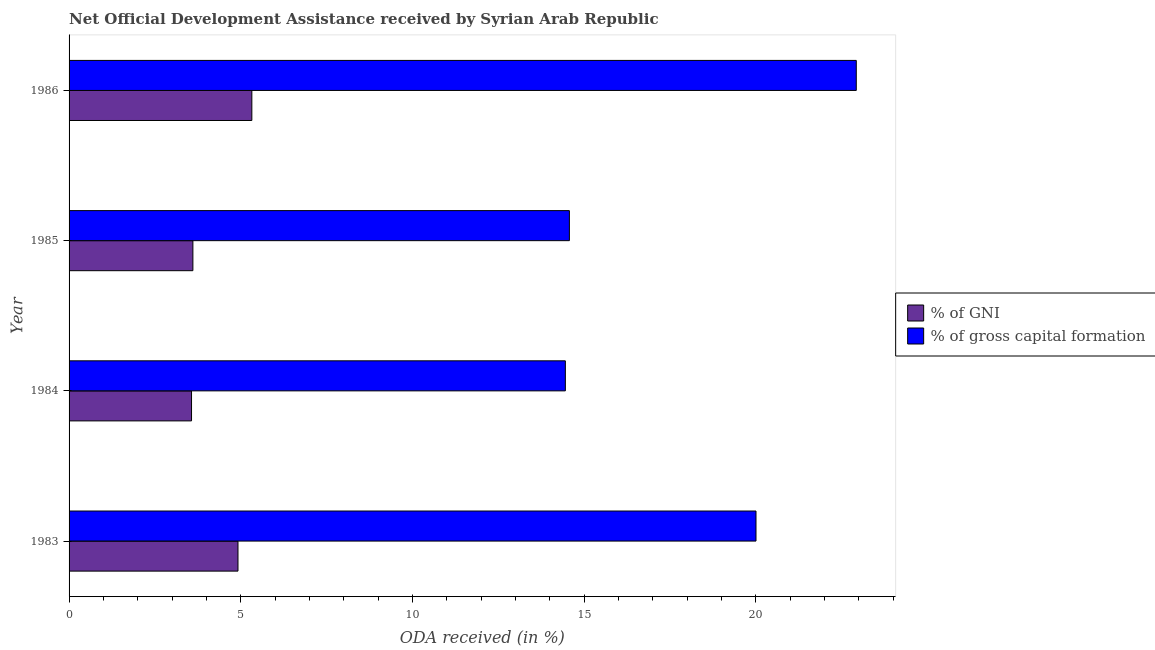How many different coloured bars are there?
Offer a terse response. 2. Are the number of bars on each tick of the Y-axis equal?
Offer a terse response. Yes. How many bars are there on the 2nd tick from the top?
Give a very brief answer. 2. What is the label of the 4th group of bars from the top?
Keep it short and to the point. 1983. What is the oda received as percentage of gni in 1983?
Your answer should be very brief. 4.92. Across all years, what is the maximum oda received as percentage of gni?
Offer a terse response. 5.32. Across all years, what is the minimum oda received as percentage of gni?
Offer a very short reply. 3.57. What is the total oda received as percentage of gross capital formation in the graph?
Offer a terse response. 71.95. What is the difference between the oda received as percentage of gross capital formation in 1983 and that in 1986?
Your response must be concise. -2.92. What is the difference between the oda received as percentage of gross capital formation in 1986 and the oda received as percentage of gni in 1984?
Keep it short and to the point. 19.36. What is the average oda received as percentage of gross capital formation per year?
Provide a succinct answer. 17.99. In the year 1986, what is the difference between the oda received as percentage of gni and oda received as percentage of gross capital formation?
Make the answer very short. -17.6. In how many years, is the oda received as percentage of gross capital formation greater than 22 %?
Provide a succinct answer. 1. What is the ratio of the oda received as percentage of gross capital formation in 1983 to that in 1984?
Make the answer very short. 1.38. Is the oda received as percentage of gni in 1984 less than that in 1986?
Keep it short and to the point. Yes. Is the difference between the oda received as percentage of gross capital formation in 1984 and 1985 greater than the difference between the oda received as percentage of gni in 1984 and 1985?
Your answer should be very brief. No. What is the difference between the highest and the second highest oda received as percentage of gni?
Provide a short and direct response. 0.4. What is the difference between the highest and the lowest oda received as percentage of gross capital formation?
Offer a very short reply. 8.47. Is the sum of the oda received as percentage of gross capital formation in 1983 and 1986 greater than the maximum oda received as percentage of gni across all years?
Ensure brevity in your answer.  Yes. What does the 2nd bar from the top in 1984 represents?
Give a very brief answer. % of GNI. What does the 2nd bar from the bottom in 1984 represents?
Ensure brevity in your answer.  % of gross capital formation. How many bars are there?
Your response must be concise. 8. Are all the bars in the graph horizontal?
Keep it short and to the point. Yes. What is the difference between two consecutive major ticks on the X-axis?
Offer a very short reply. 5. Does the graph contain any zero values?
Your response must be concise. No. Does the graph contain grids?
Provide a short and direct response. No. Where does the legend appear in the graph?
Your response must be concise. Center right. What is the title of the graph?
Your answer should be compact. Net Official Development Assistance received by Syrian Arab Republic. What is the label or title of the X-axis?
Give a very brief answer. ODA received (in %). What is the ODA received (in %) of % of GNI in 1983?
Offer a very short reply. 4.92. What is the ODA received (in %) in % of gross capital formation in 1983?
Your answer should be compact. 20. What is the ODA received (in %) in % of GNI in 1984?
Offer a very short reply. 3.57. What is the ODA received (in %) in % of gross capital formation in 1984?
Offer a terse response. 14.45. What is the ODA received (in %) in % of GNI in 1985?
Make the answer very short. 3.61. What is the ODA received (in %) of % of gross capital formation in 1985?
Ensure brevity in your answer.  14.57. What is the ODA received (in %) in % of GNI in 1986?
Provide a short and direct response. 5.32. What is the ODA received (in %) of % of gross capital formation in 1986?
Your answer should be very brief. 22.93. Across all years, what is the maximum ODA received (in %) in % of GNI?
Provide a succinct answer. 5.32. Across all years, what is the maximum ODA received (in %) in % of gross capital formation?
Offer a very short reply. 22.93. Across all years, what is the minimum ODA received (in %) of % of GNI?
Your response must be concise. 3.57. Across all years, what is the minimum ODA received (in %) of % of gross capital formation?
Make the answer very short. 14.45. What is the total ODA received (in %) in % of GNI in the graph?
Ensure brevity in your answer.  17.41. What is the total ODA received (in %) of % of gross capital formation in the graph?
Your answer should be very brief. 71.95. What is the difference between the ODA received (in %) of % of GNI in 1983 and that in 1984?
Your answer should be compact. 1.35. What is the difference between the ODA received (in %) in % of gross capital formation in 1983 and that in 1984?
Provide a short and direct response. 5.55. What is the difference between the ODA received (in %) of % of GNI in 1983 and that in 1985?
Ensure brevity in your answer.  1.31. What is the difference between the ODA received (in %) of % of gross capital formation in 1983 and that in 1985?
Your answer should be very brief. 5.43. What is the difference between the ODA received (in %) of % of GNI in 1983 and that in 1986?
Your answer should be very brief. -0.4. What is the difference between the ODA received (in %) of % of gross capital formation in 1983 and that in 1986?
Provide a succinct answer. -2.92. What is the difference between the ODA received (in %) of % of GNI in 1984 and that in 1985?
Your answer should be compact. -0.04. What is the difference between the ODA received (in %) in % of gross capital formation in 1984 and that in 1985?
Offer a very short reply. -0.12. What is the difference between the ODA received (in %) in % of GNI in 1984 and that in 1986?
Keep it short and to the point. -1.76. What is the difference between the ODA received (in %) in % of gross capital formation in 1984 and that in 1986?
Make the answer very short. -8.47. What is the difference between the ODA received (in %) of % of GNI in 1985 and that in 1986?
Give a very brief answer. -1.72. What is the difference between the ODA received (in %) in % of gross capital formation in 1985 and that in 1986?
Your answer should be very brief. -8.35. What is the difference between the ODA received (in %) of % of GNI in 1983 and the ODA received (in %) of % of gross capital formation in 1984?
Offer a very short reply. -9.53. What is the difference between the ODA received (in %) of % of GNI in 1983 and the ODA received (in %) of % of gross capital formation in 1985?
Your answer should be compact. -9.65. What is the difference between the ODA received (in %) of % of GNI in 1983 and the ODA received (in %) of % of gross capital formation in 1986?
Offer a terse response. -18.01. What is the difference between the ODA received (in %) of % of GNI in 1984 and the ODA received (in %) of % of gross capital formation in 1985?
Your response must be concise. -11. What is the difference between the ODA received (in %) in % of GNI in 1984 and the ODA received (in %) in % of gross capital formation in 1986?
Provide a short and direct response. -19.36. What is the difference between the ODA received (in %) in % of GNI in 1985 and the ODA received (in %) in % of gross capital formation in 1986?
Your answer should be compact. -19.32. What is the average ODA received (in %) in % of GNI per year?
Offer a very short reply. 4.35. What is the average ODA received (in %) in % of gross capital formation per year?
Make the answer very short. 17.99. In the year 1983, what is the difference between the ODA received (in %) in % of GNI and ODA received (in %) in % of gross capital formation?
Your answer should be very brief. -15.09. In the year 1984, what is the difference between the ODA received (in %) of % of GNI and ODA received (in %) of % of gross capital formation?
Give a very brief answer. -10.89. In the year 1985, what is the difference between the ODA received (in %) of % of GNI and ODA received (in %) of % of gross capital formation?
Ensure brevity in your answer.  -10.96. In the year 1986, what is the difference between the ODA received (in %) in % of GNI and ODA received (in %) in % of gross capital formation?
Your answer should be very brief. -17.6. What is the ratio of the ODA received (in %) in % of GNI in 1983 to that in 1984?
Offer a terse response. 1.38. What is the ratio of the ODA received (in %) in % of gross capital formation in 1983 to that in 1984?
Keep it short and to the point. 1.38. What is the ratio of the ODA received (in %) in % of GNI in 1983 to that in 1985?
Your response must be concise. 1.36. What is the ratio of the ODA received (in %) in % of gross capital formation in 1983 to that in 1985?
Your answer should be compact. 1.37. What is the ratio of the ODA received (in %) of % of GNI in 1983 to that in 1986?
Give a very brief answer. 0.92. What is the ratio of the ODA received (in %) of % of gross capital formation in 1983 to that in 1986?
Ensure brevity in your answer.  0.87. What is the ratio of the ODA received (in %) of % of GNI in 1984 to that in 1985?
Ensure brevity in your answer.  0.99. What is the ratio of the ODA received (in %) of % of GNI in 1984 to that in 1986?
Your answer should be very brief. 0.67. What is the ratio of the ODA received (in %) of % of gross capital formation in 1984 to that in 1986?
Keep it short and to the point. 0.63. What is the ratio of the ODA received (in %) of % of GNI in 1985 to that in 1986?
Provide a short and direct response. 0.68. What is the ratio of the ODA received (in %) of % of gross capital formation in 1985 to that in 1986?
Offer a very short reply. 0.64. What is the difference between the highest and the second highest ODA received (in %) of % of GNI?
Your answer should be compact. 0.4. What is the difference between the highest and the second highest ODA received (in %) of % of gross capital formation?
Offer a terse response. 2.92. What is the difference between the highest and the lowest ODA received (in %) of % of GNI?
Give a very brief answer. 1.76. What is the difference between the highest and the lowest ODA received (in %) in % of gross capital formation?
Offer a very short reply. 8.47. 